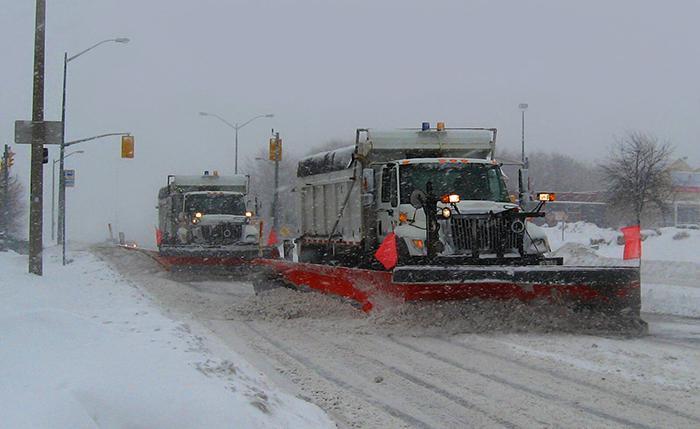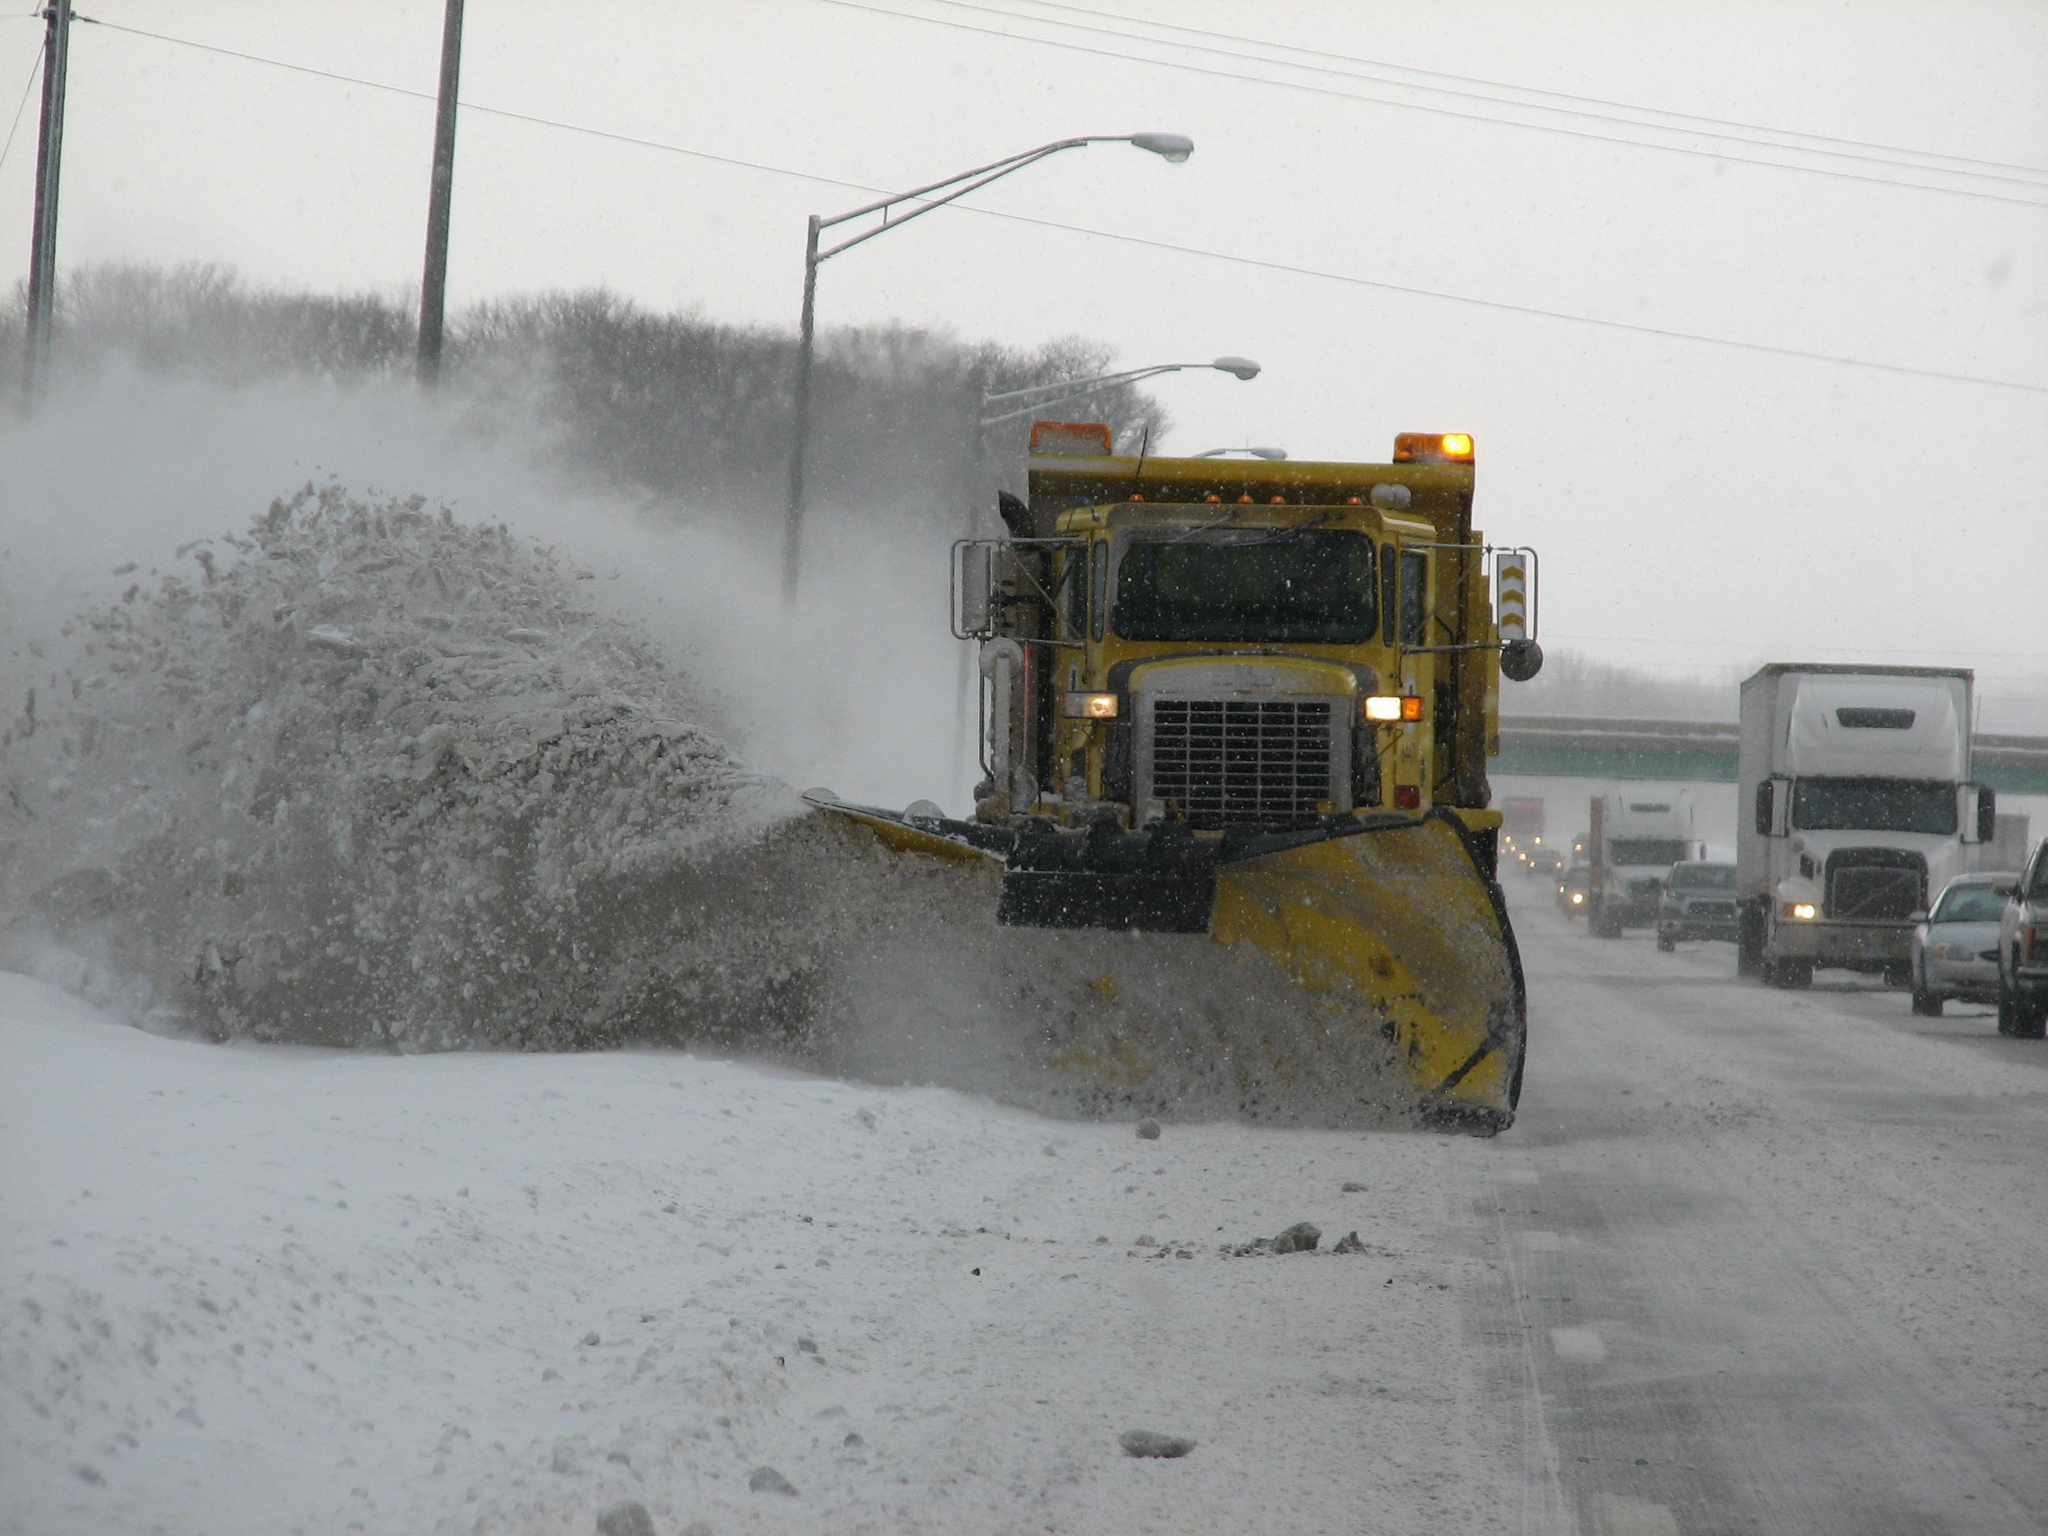The first image is the image on the left, the second image is the image on the right. Analyze the images presented: Is the assertion "The truck in one of the images has a red plow." valid? Answer yes or no. Yes. 